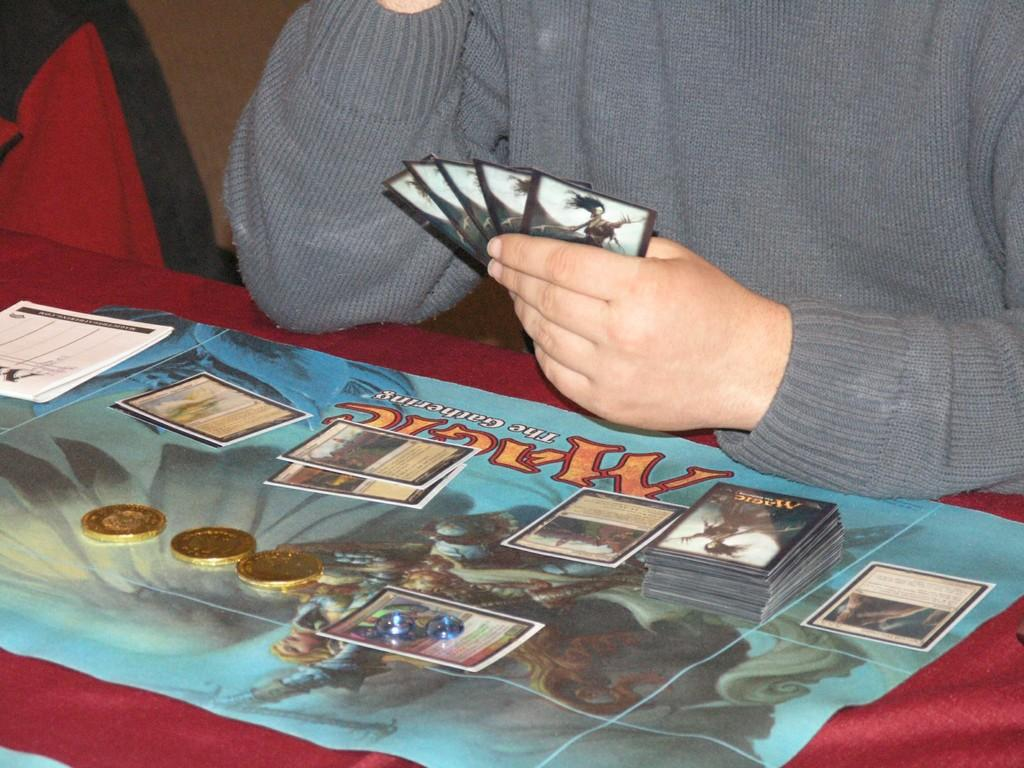What can be seen in the image related to a person? There is a person in the image, but their face is not visible. What is the person wearing? The person is wearing clothes. What is the person holding in the image? The person is holding cards. What is present on the table in the image? There is a table in the image that contains cards and coins. What type of lettuce can be seen growing on the table in the image? There is no lettuce present in the image; the table contains cards and coins. What kind of rose is being played by the person in the image? There is no rose or instrument present in the image; the person is holding cards. 